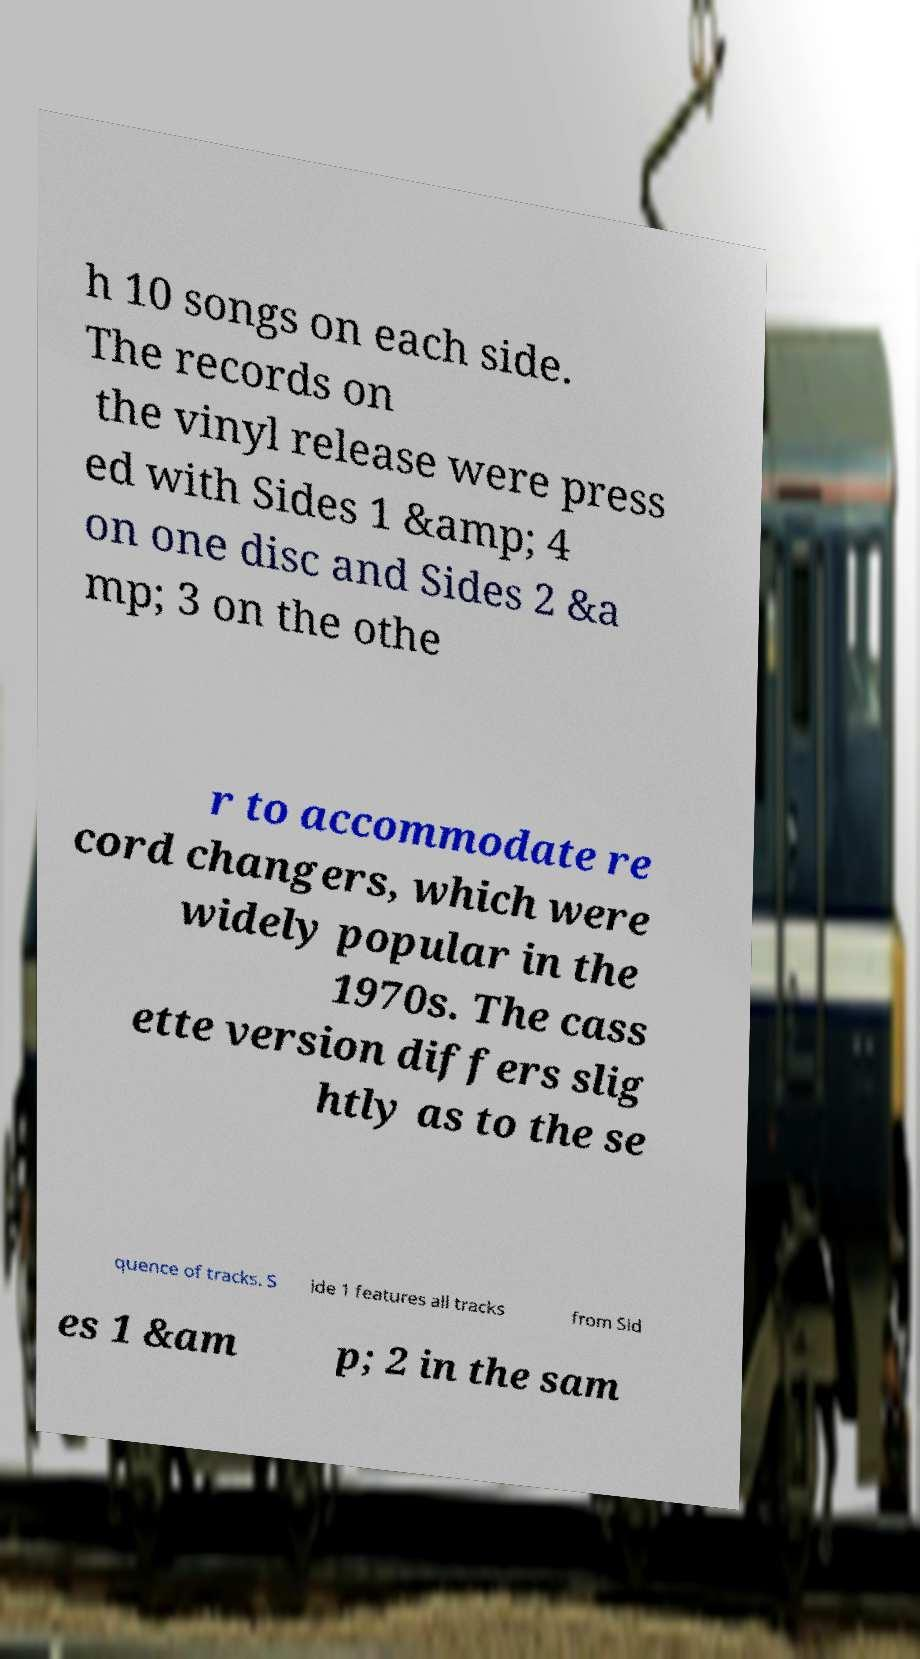Please identify and transcribe the text found in this image. h 10 songs on each side. The records on the vinyl release were press ed with Sides 1 &amp; 4 on one disc and Sides 2 &a mp; 3 on the othe r to accommodate re cord changers, which were widely popular in the 1970s. The cass ette version differs slig htly as to the se quence of tracks. S ide 1 features all tracks from Sid es 1 &am p; 2 in the sam 